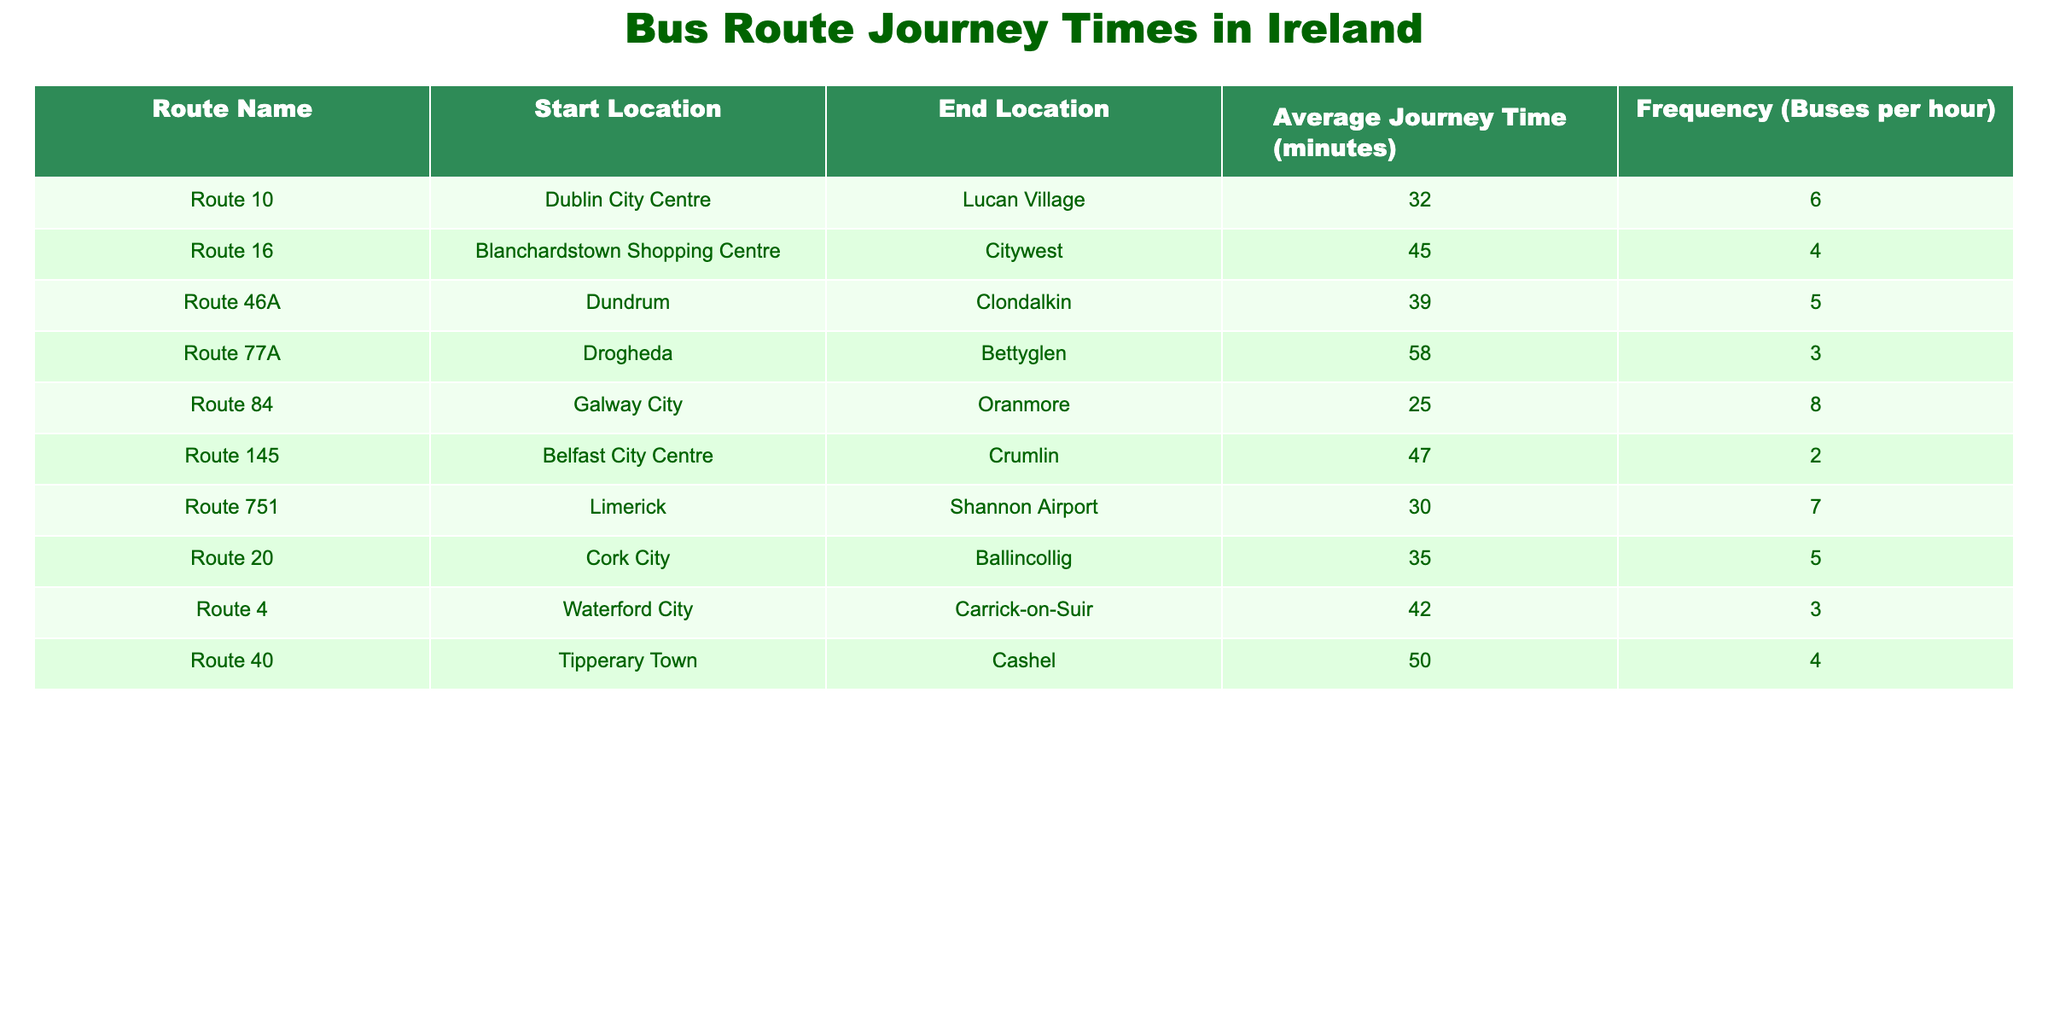What is the average journey time for Route 10? Looking at the table, Route 10 has an average journey time listed as 32 minutes.
Answer: 32 minutes How many buses per hour run on Route 16? The table indicates that Route 16 has a frequency of 4 buses per hour.
Answer: 4 buses per hour What is the total journey time for Route 77A and Route 40 combined? Route 77A has an average journey time of 58 minutes, and Route 40 has an average journey time of 50 minutes. When summed, 58 + 50 gives a total of 108 minutes.
Answer: 108 minutes Is the average journey time for the Cork City to Ballincollig route longer than that of the Galway City to Oranmore route? The average journey time for Route 20 (Cork City to Ballincollig) is 35 minutes, while for Route 84 (Galway City to Oranmore) it is 25 minutes. Since 35 is greater than 25, the answer is yes.
Answer: Yes What is the median average journey time of all the routes listed? First, we list all average journey times: [32, 45, 39, 58, 25, 47, 30, 35, 42, 50]. Arranging these in order gives us [25, 30, 32, 35, 39, 42, 45, 47, 50, 58]. Since there are 10 values, the median is the average of the 5th and 6th values, which are 39 and 42. Their average is (39 + 42) / 2 = 40.5 minutes.
Answer: 40.5 minutes How does the frequency of Route 84 compare with Route 46A? Route 84 has a frequency of 8 buses per hour while Route 46A has a frequency of 5 buses per hour. Since 8 is greater than 5, Route 84 has a higher frequency.
Answer: Higher Which route has the longest average journey time? By examining the table, Route 77A has the highest average journey time at 58 minutes.
Answer: Route 77A 